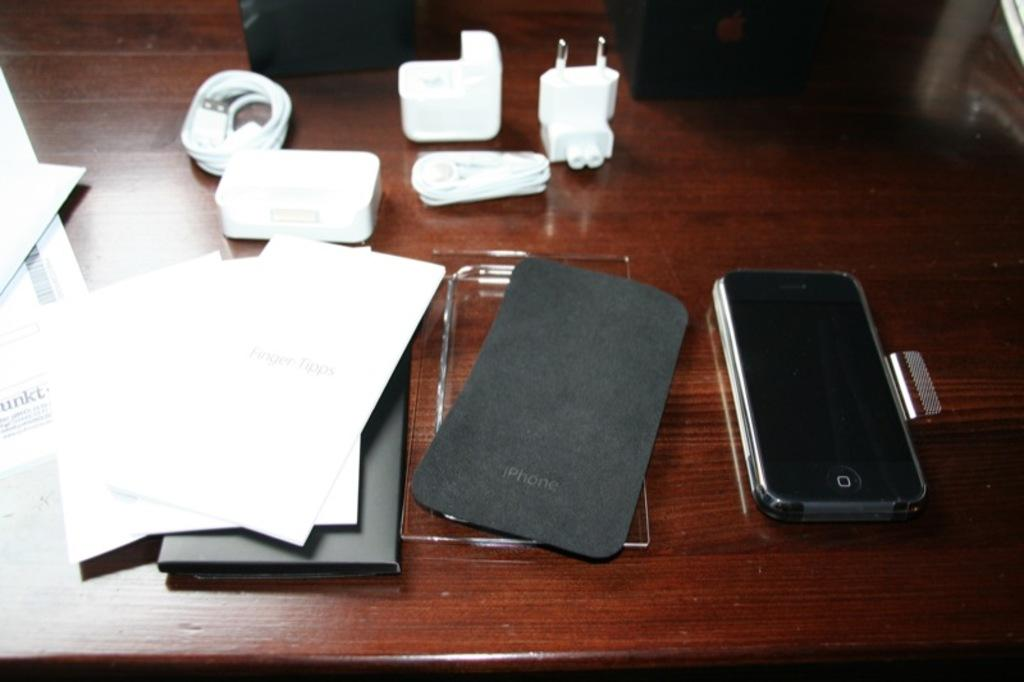<image>
Offer a succinct explanation of the picture presented. an iphone is sitting on a desk with all of the things needed to charge it 